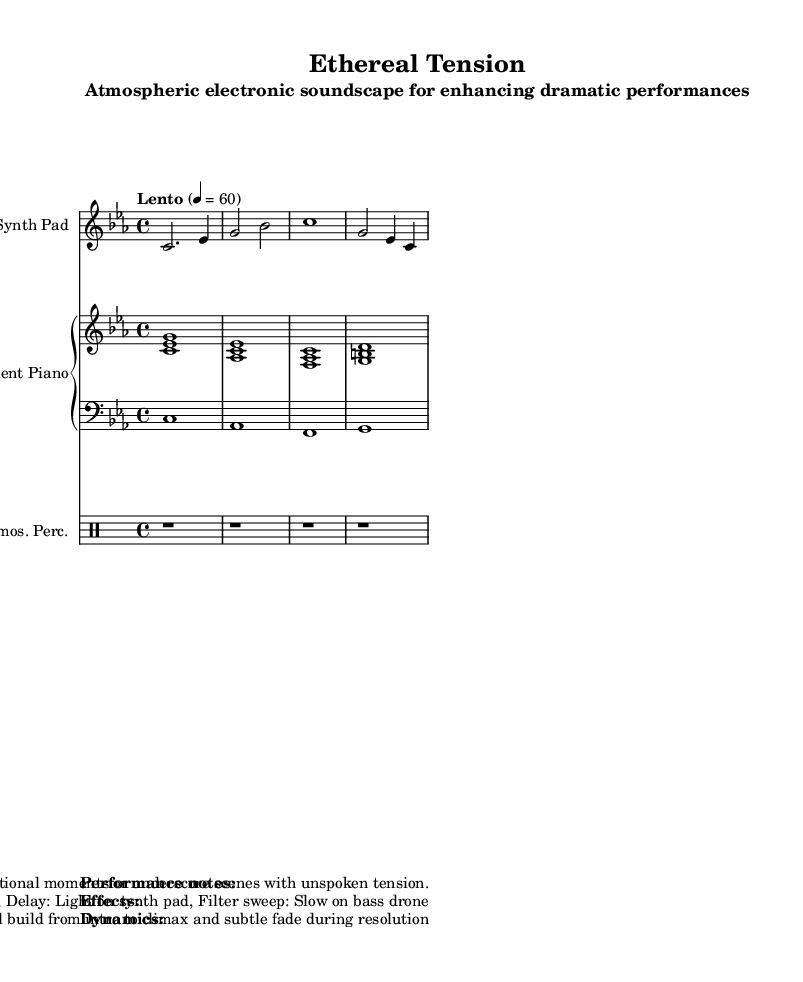What is the key signature of this music? The key signature indicates the music is in C minor, which is represented by three flats (B♭, E♭, A♭) in the key signature shown at the beginning of the staff.
Answer: C minor What is the time signature of the piece? The time signature is shown on the left side of the sheet music, indicating that there are four beats per measure, which corresponds to a 4/4 time.
Answer: 4/4 What is the tempo marking of this piece? The tempo marking is provided just above the staff, indicating a slow pace of 60 beats per minute, denoted by "Lento 4 = 60."
Answer: Lento 4 = 60 How many measures are present in the synth part? By counting the measures represented in the synth voice, there are four distinct measures indicated in the sheet music.
Answer: 4 What is the dynamic range specified in the performance notes? The performance notes describe the dynamics as gradually building from very soft (pp) to moderately loud (mf), suggesting a range of soft to medium loudness throughout the piece.
Answer: pp to mf Which instrument has the melody in this composition? The synth pad, notated specifically, carries the melodic line with the notes it plays, indicating that it is the lead instrument in this atmospheric piece.
Answer: Synth Pad What is the primary effect suggested for the instruments? The performance notes specify that heavy reverb is recommended for all instruments, primarily to enhance the atmospheric feel of the piece, creating a spacious sound.
Answer: Reverb 